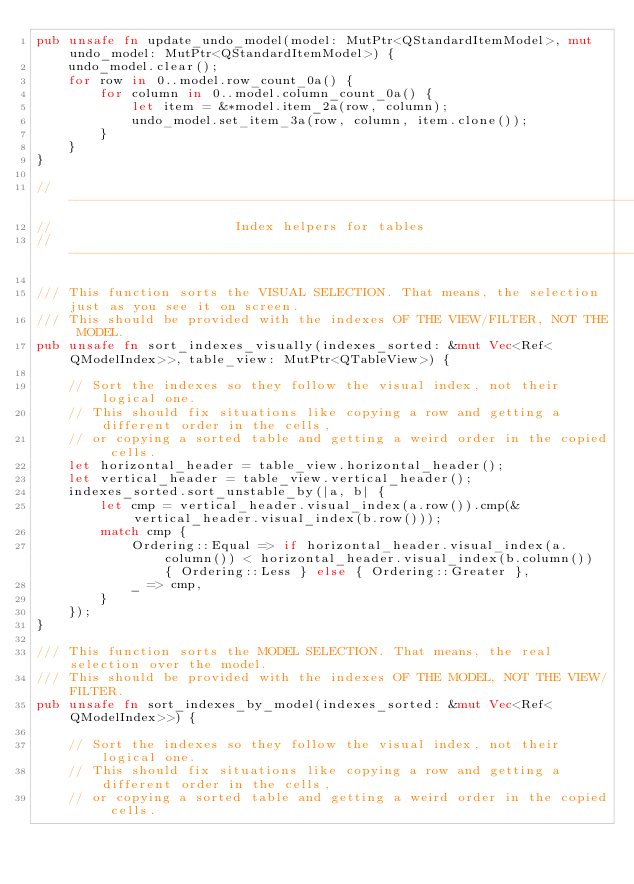Convert code to text. <code><loc_0><loc_0><loc_500><loc_500><_Rust_>pub unsafe fn update_undo_model(model: MutPtr<QStandardItemModel>, mut undo_model: MutPtr<QStandardItemModel>) {
    undo_model.clear();
    for row in 0..model.row_count_0a() {
        for column in 0..model.column_count_0a() {
            let item = &*model.item_2a(row, column);
            undo_model.set_item_3a(row, column, item.clone());
        }
    }
}

//----------------------------------------------------------------------------//
//                       Index helpers for tables
//----------------------------------------------------------------------------//

/// This function sorts the VISUAL SELECTION. That means, the selection just as you see it on screen.
/// This should be provided with the indexes OF THE VIEW/FILTER, NOT THE MODEL.
pub unsafe fn sort_indexes_visually(indexes_sorted: &mut Vec<Ref<QModelIndex>>, table_view: MutPtr<QTableView>) {

    // Sort the indexes so they follow the visual index, not their logical one.
    // This should fix situations like copying a row and getting a different order in the cells,
    // or copying a sorted table and getting a weird order in the copied cells.
    let horizontal_header = table_view.horizontal_header();
    let vertical_header = table_view.vertical_header();
    indexes_sorted.sort_unstable_by(|a, b| {
        let cmp = vertical_header.visual_index(a.row()).cmp(&vertical_header.visual_index(b.row()));
        match cmp {
            Ordering::Equal => if horizontal_header.visual_index(a.column()) < horizontal_header.visual_index(b.column()) { Ordering::Less } else { Ordering::Greater },
            _ => cmp,
        }
    });
}

/// This function sorts the MODEL SELECTION. That means, the real selection over the model.
/// This should be provided with the indexes OF THE MODEL, NOT THE VIEW/FILTER.
pub unsafe fn sort_indexes_by_model(indexes_sorted: &mut Vec<Ref<QModelIndex>>) {

    // Sort the indexes so they follow the visual index, not their logical one.
    // This should fix situations like copying a row and getting a different order in the cells,
    // or copying a sorted table and getting a weird order in the copied cells.</code> 